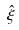Convert formula to latex. <formula><loc_0><loc_0><loc_500><loc_500>\hat { \xi }</formula> 